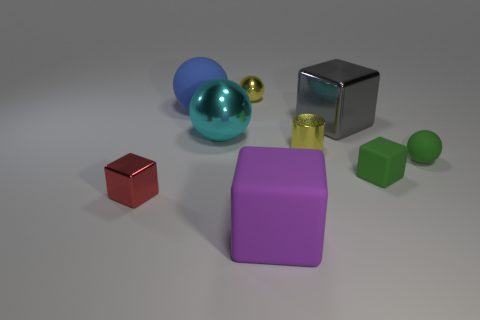Subtract all green rubber cubes. How many cubes are left? 3 Add 1 large gray metal things. How many objects exist? 10 Subtract all red cubes. How many cubes are left? 3 Subtract all cylinders. How many objects are left? 8 Add 3 tiny green cubes. How many tiny green cubes are left? 4 Add 6 small metal spheres. How many small metal spheres exist? 7 Subtract 0 gray cylinders. How many objects are left? 9 Subtract all yellow balls. Subtract all cyan blocks. How many balls are left? 3 Subtract all tiny brown shiny cubes. Subtract all metal cylinders. How many objects are left? 8 